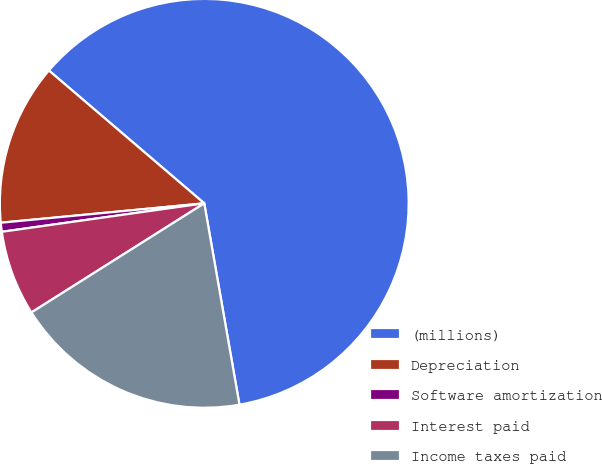<chart> <loc_0><loc_0><loc_500><loc_500><pie_chart><fcel>(millions)<fcel>Depreciation<fcel>Software amortization<fcel>Interest paid<fcel>Income taxes paid<nl><fcel>60.98%<fcel>12.77%<fcel>0.71%<fcel>6.74%<fcel>18.79%<nl></chart> 